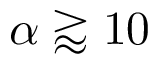Convert formula to latex. <formula><loc_0><loc_0><loc_500><loc_500>\alpha \gtrapprox 1 0</formula> 